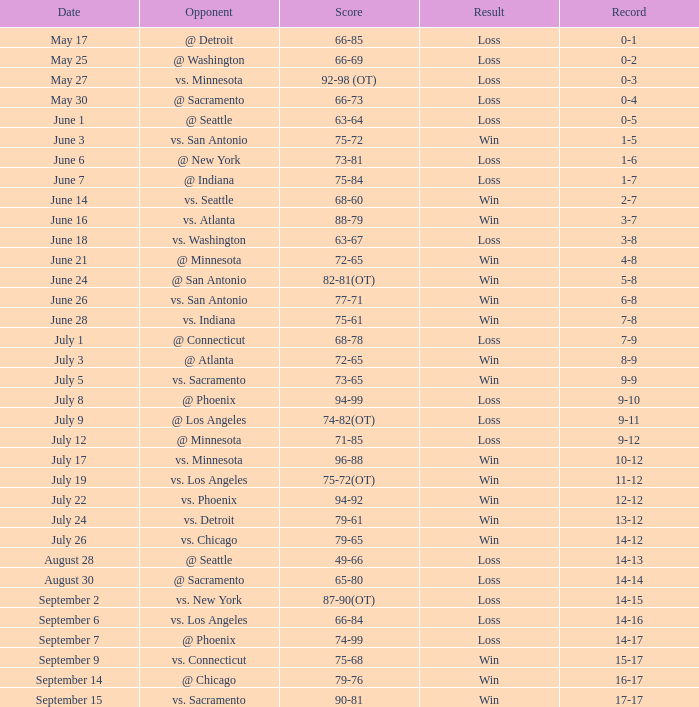What is the Record of the game on June 24? 5-8. 